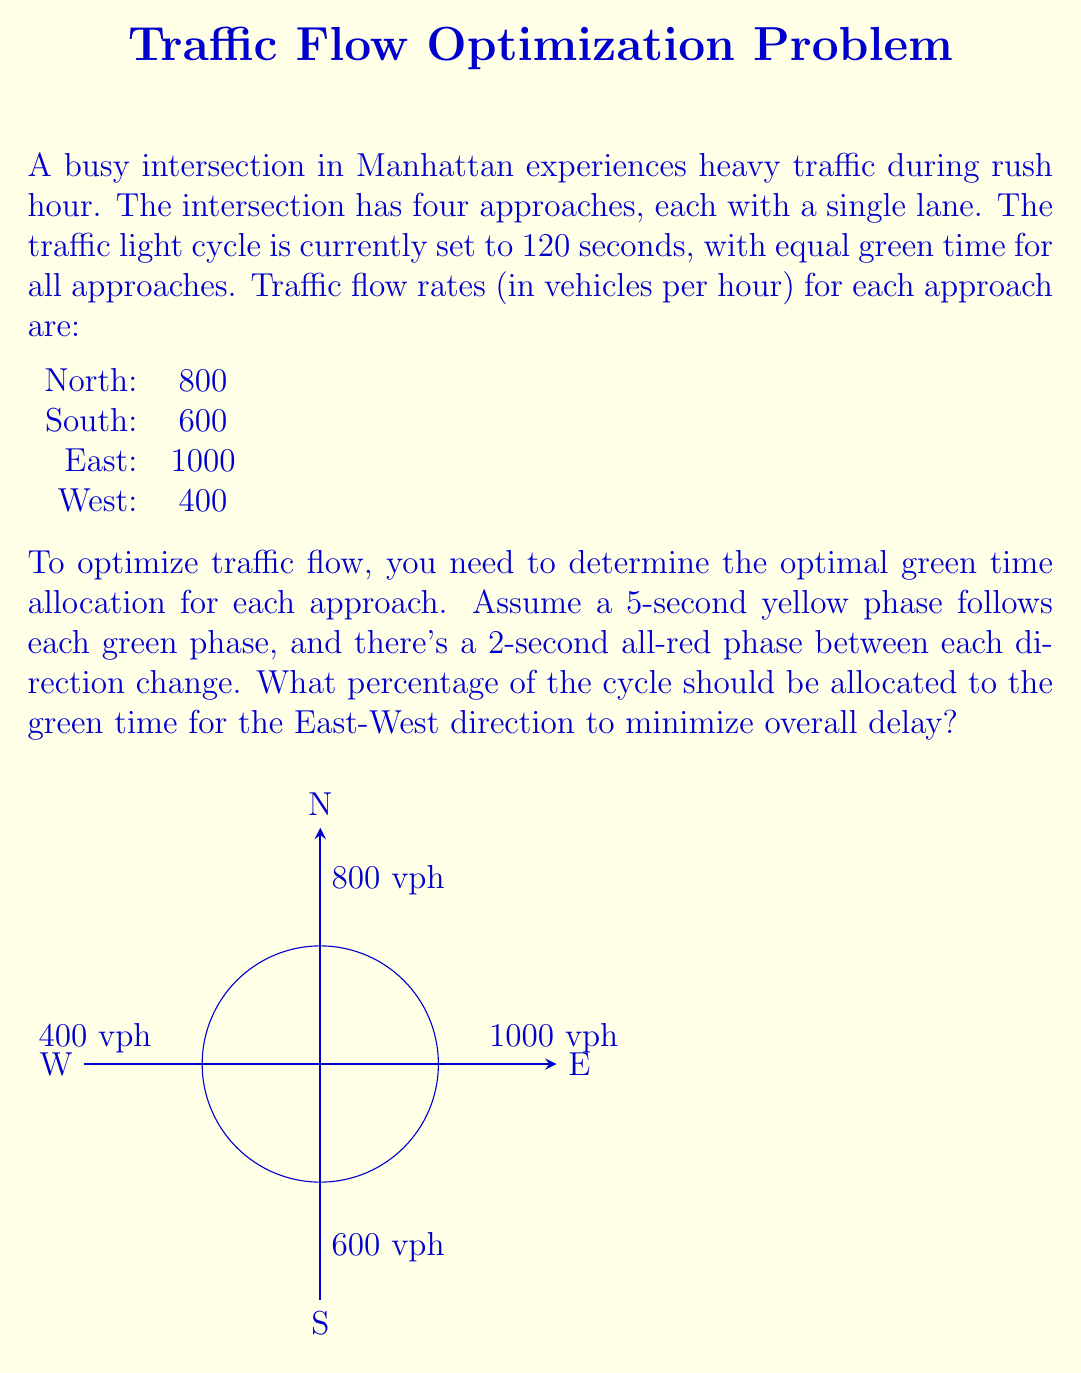Could you help me with this problem? Let's approach this step-by-step:

1) First, we need to calculate the total traffic flow:
   $800 + 600 + 1000 + 400 = 2800$ vehicles per hour

2) The cycle length is 120 seconds. We need to account for the yellow and all-red phases:
   - 4 yellow phases of 5 seconds each: $4 * 5 = 20$ seconds
   - 4 all-red phases of 2 seconds each: $4 * 2 = 8$ seconds
   Total non-green time: $20 + 8 = 28$ seconds

3) Remaining time for green phases: $120 - 28 = 92$ seconds

4) We want to allocate green time proportionally to the traffic flow in each direction:
   North-South: $800 + 600 = 1400$ vph
   East-West: $1000 + 400 = 1400$ vph

5) Since the flow is equal in both directions, we should allocate equal green time:
   $92 / 2 = 46$ seconds for each direction

6) For East-West direction:
   Green time: 46 seconds
   Yellow time: 5 seconds
   Total East-West time: $46 + 5 = 51$ seconds

7) Percentage of cycle for East-West direction:
   $$(51 / 120) * 100 = 42.5\%$$

Therefore, to minimize overall delay, 42.5% of the cycle should be allocated to the East-West direction (including green and yellow phases).
Answer: 42.5% 